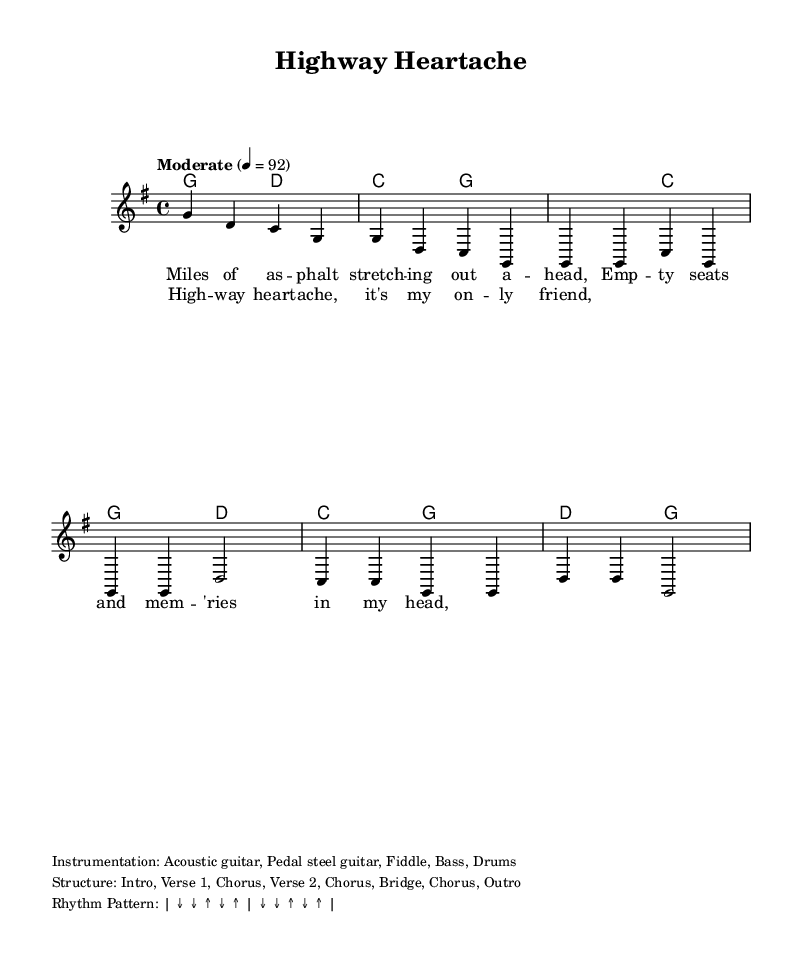What is the key signature of this music? The key signature is G major, which has one sharp (F#). This is noticeable in the global section stating \key g \major.
Answer: G major What is the time signature of this music? The time signature is 4/4, which indicates there are four beats in each measure. This is also mentioned in the global section with \time 4/4.
Answer: 4/4 What is the tempo marking for this piece? The tempo marking indicates "Moderate" at a speed of 92 beats per minute, specified by the command \tempo "Moderate" 4 = 92.
Answer: Moderate How many measures are in the provided section of the music? Counting the measures in the melody, there are a total of six measures shown in the intro and verse. Each line contributes to this total.
Answer: Six What instruments are listed for this piece? The instrumentation includes Acoustic guitar, Pedal steel guitar, Fiddle, Bass, and Drums, which are detailed in the markup section at the bottom of the score.
Answer: Acoustic guitar, Pedal steel guitar, Fiddle, Bass, Drums Which part of the song is the first lyric from? The first lyric "Miles of asphalt stretching out ahead" is from the verse section as indicated by the label \lyricsto "lead".
Answer: Verse What structure section follows the intro? The structure after the intro is Verse 1, as it is stated in the markup section outlining the layout of the song.
Answer: Verse 1 